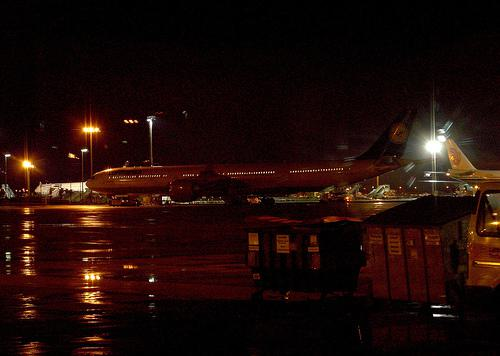What are the airlines visible in the image? The image displays planes from various airlines, but due to the nighttime setting and distance, specific airline names are not clearly visible. 